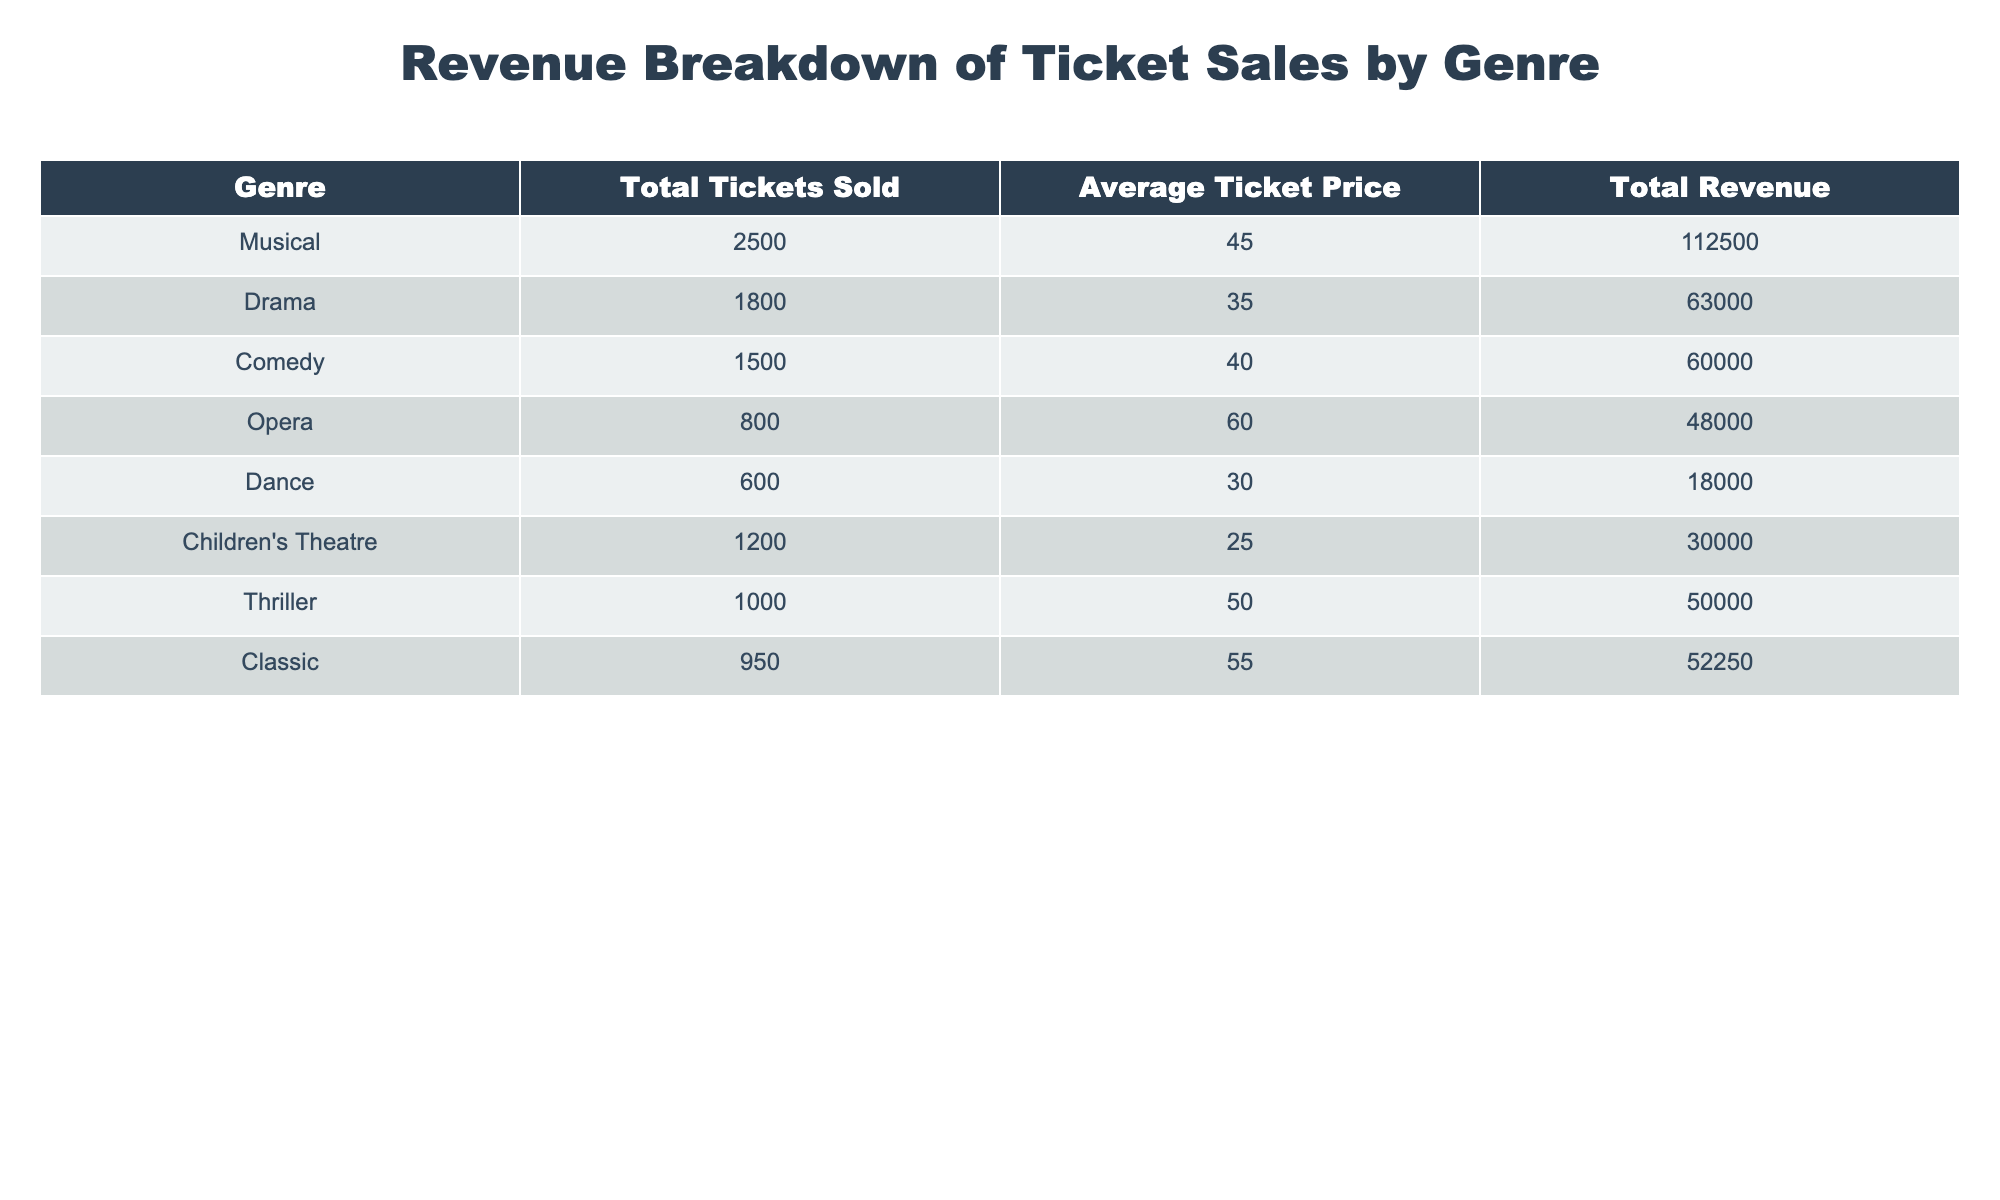What genre sold the most tickets? The table indicates that the Genre with the highest total tickets sold is "Musical," with a total of 2,500 tickets sold.
Answer: Musical What is the average ticket price for the Comedy genre? The Comedy genre has an average ticket price of 40, as stated directly in the table.
Answer: 40 How much total revenue did Dance generate? According to the table, the Dance genre generated a total revenue of 18,000. This is directly available under the Total Revenue column for Dance.
Answer: 18000 Which genre had the lowest average ticket price? From the data, Dance has the lowest average ticket price at 30. This is determined by comparing the Average Ticket Price across all genres in the table.
Answer: Dance What is the total revenue generated from all genres combined? Adding up all the revenue figures: 112,500 (Musical) + 63,000 (Drama) + 60,000 (Comedy) + 48,000 (Opera) + 18,000 (Dance) + 30,000 (Children's Theatre) + 50,000 (Thriller) + 52,250 (Classic) equals a total revenue of 381,750.
Answer: 381750 Did Children's Theatre generate more revenue than Opera? The total revenue for Children's Theatre is 30,000, while Opera generated 48,000. Since 30,000 is less than 48,000, the statement is false.
Answer: No What is the average revenue per ticket sold for the Thriller genre? First, we will find the average revenue per ticket by dividing Total Revenue by Total Tickets Sold for the Thriller genre: 50,000 / 1,000 = 50.
Answer: 50 Is the average ticket price for the Classic genre higher than that for Drama? The average ticket price for Classic is 55, while for Drama it is 35. Since 55 is greater than 35, the statement is true.
Answer: Yes What is the difference in total tickets sold between Musical and Thriller? The total tickets sold for Musical is 2,500 and for Thriller it is 1,000. The difference is 2,500 - 1,000 = 1,500.
Answer: 1500 